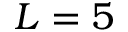<formula> <loc_0><loc_0><loc_500><loc_500>L = 5</formula> 